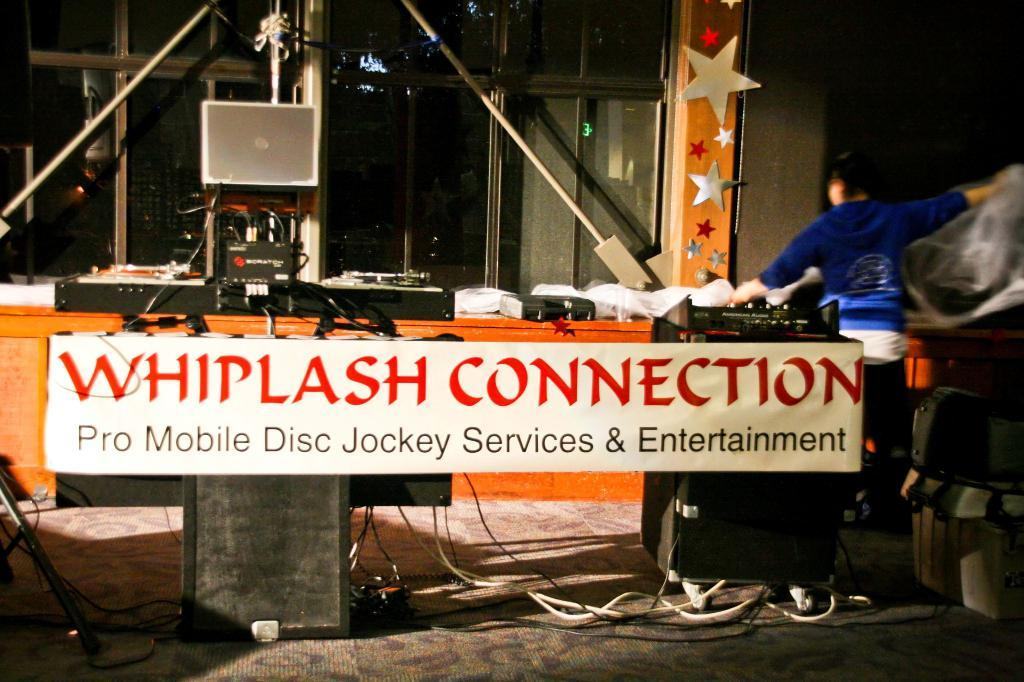Who or what is present in the image? There is a person in the image. What is the person interacting with in the image? There is a board in the image, which the person might be interacting with. What other objects can be seen in the image? There are rods, decorative items, devices, cables, a bag, and other objects in the image. What type of punishment is being administered to the person in the image? There is no indication of punishment in the image; it simply shows a person interacting with a board and other objects. What type of stove is visible in the image? There is no stove present in the image. 